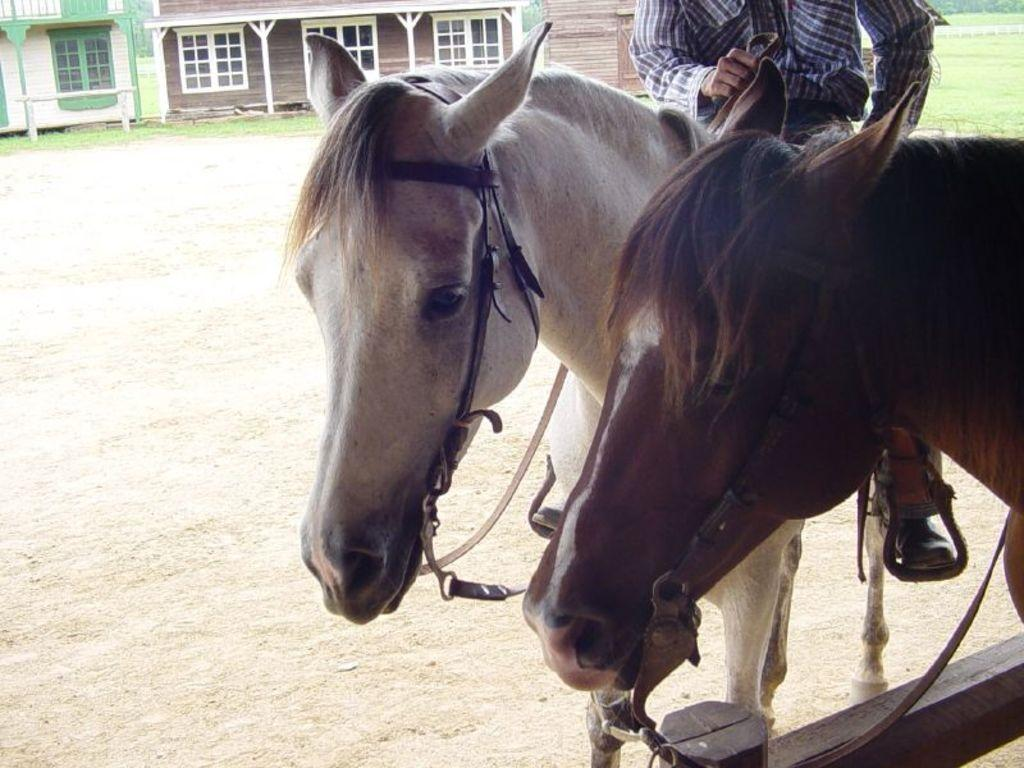What type of animal is on the right side of the image? There is a brown horse on the right side of the image. Is there another horse in the image? Yes, there is a white horse beside the brown horse. What structure can be seen on the left side of the image? There appears to be a house on the left side of the image. Can you see any popcorn on the ground near the horses? There is no popcorn present in the image. Is the image taken on an island? The provided facts do not mention anything about an island, so we cannot determine if the image was taken on one. 